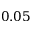Convert formula to latex. <formula><loc_0><loc_0><loc_500><loc_500>0 . 0 5</formula> 